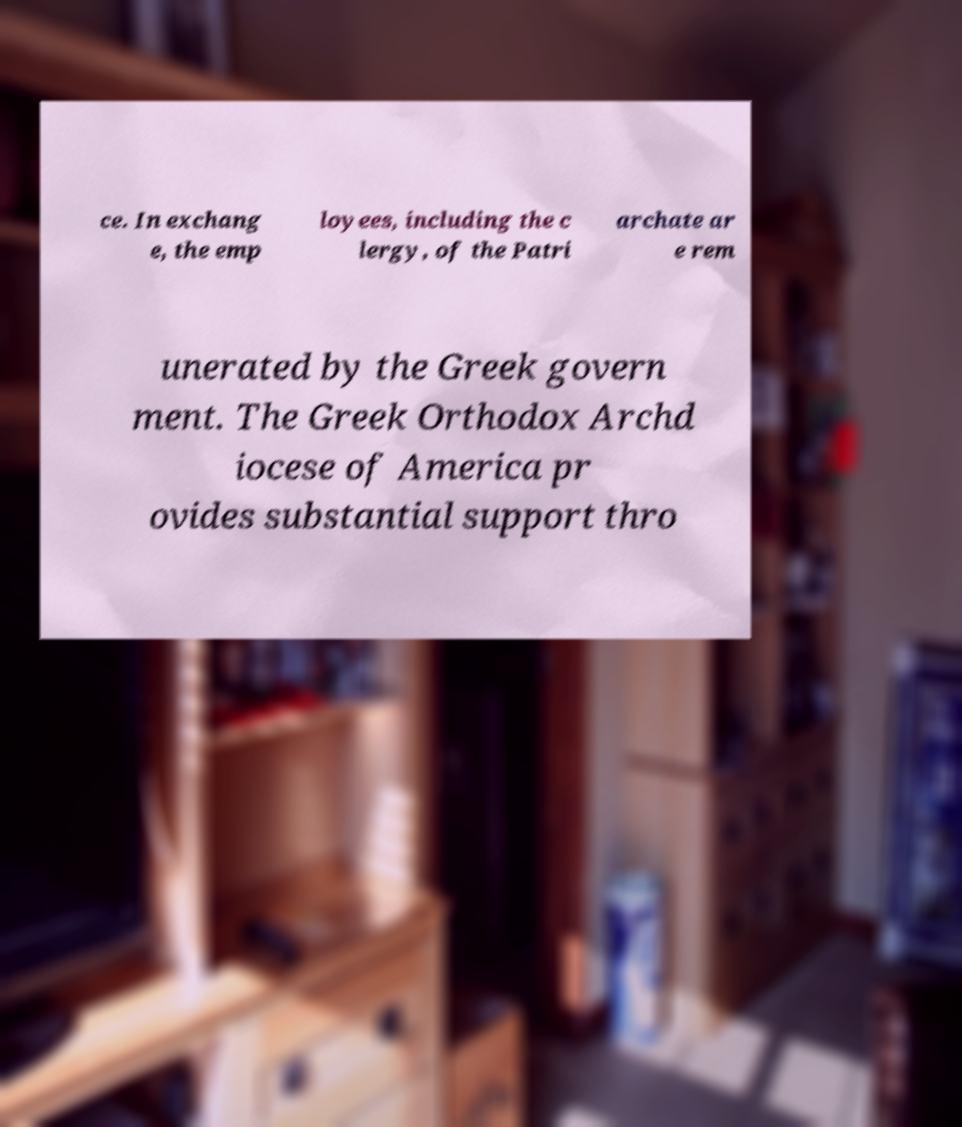Could you assist in decoding the text presented in this image and type it out clearly? ce. In exchang e, the emp loyees, including the c lergy, of the Patri archate ar e rem unerated by the Greek govern ment. The Greek Orthodox Archd iocese of America pr ovides substantial support thro 